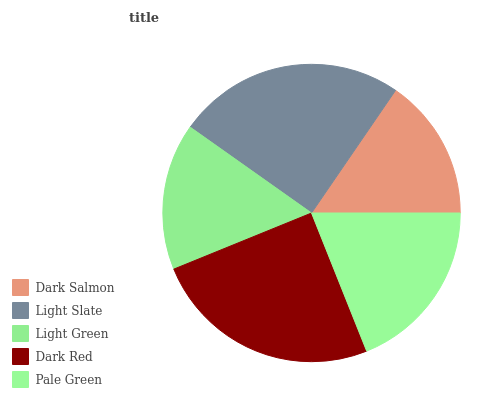Is Dark Salmon the minimum?
Answer yes or no. Yes. Is Dark Red the maximum?
Answer yes or no. Yes. Is Light Slate the minimum?
Answer yes or no. No. Is Light Slate the maximum?
Answer yes or no. No. Is Light Slate greater than Dark Salmon?
Answer yes or no. Yes. Is Dark Salmon less than Light Slate?
Answer yes or no. Yes. Is Dark Salmon greater than Light Slate?
Answer yes or no. No. Is Light Slate less than Dark Salmon?
Answer yes or no. No. Is Pale Green the high median?
Answer yes or no. Yes. Is Pale Green the low median?
Answer yes or no. Yes. Is Light Slate the high median?
Answer yes or no. No. Is Light Slate the low median?
Answer yes or no. No. 